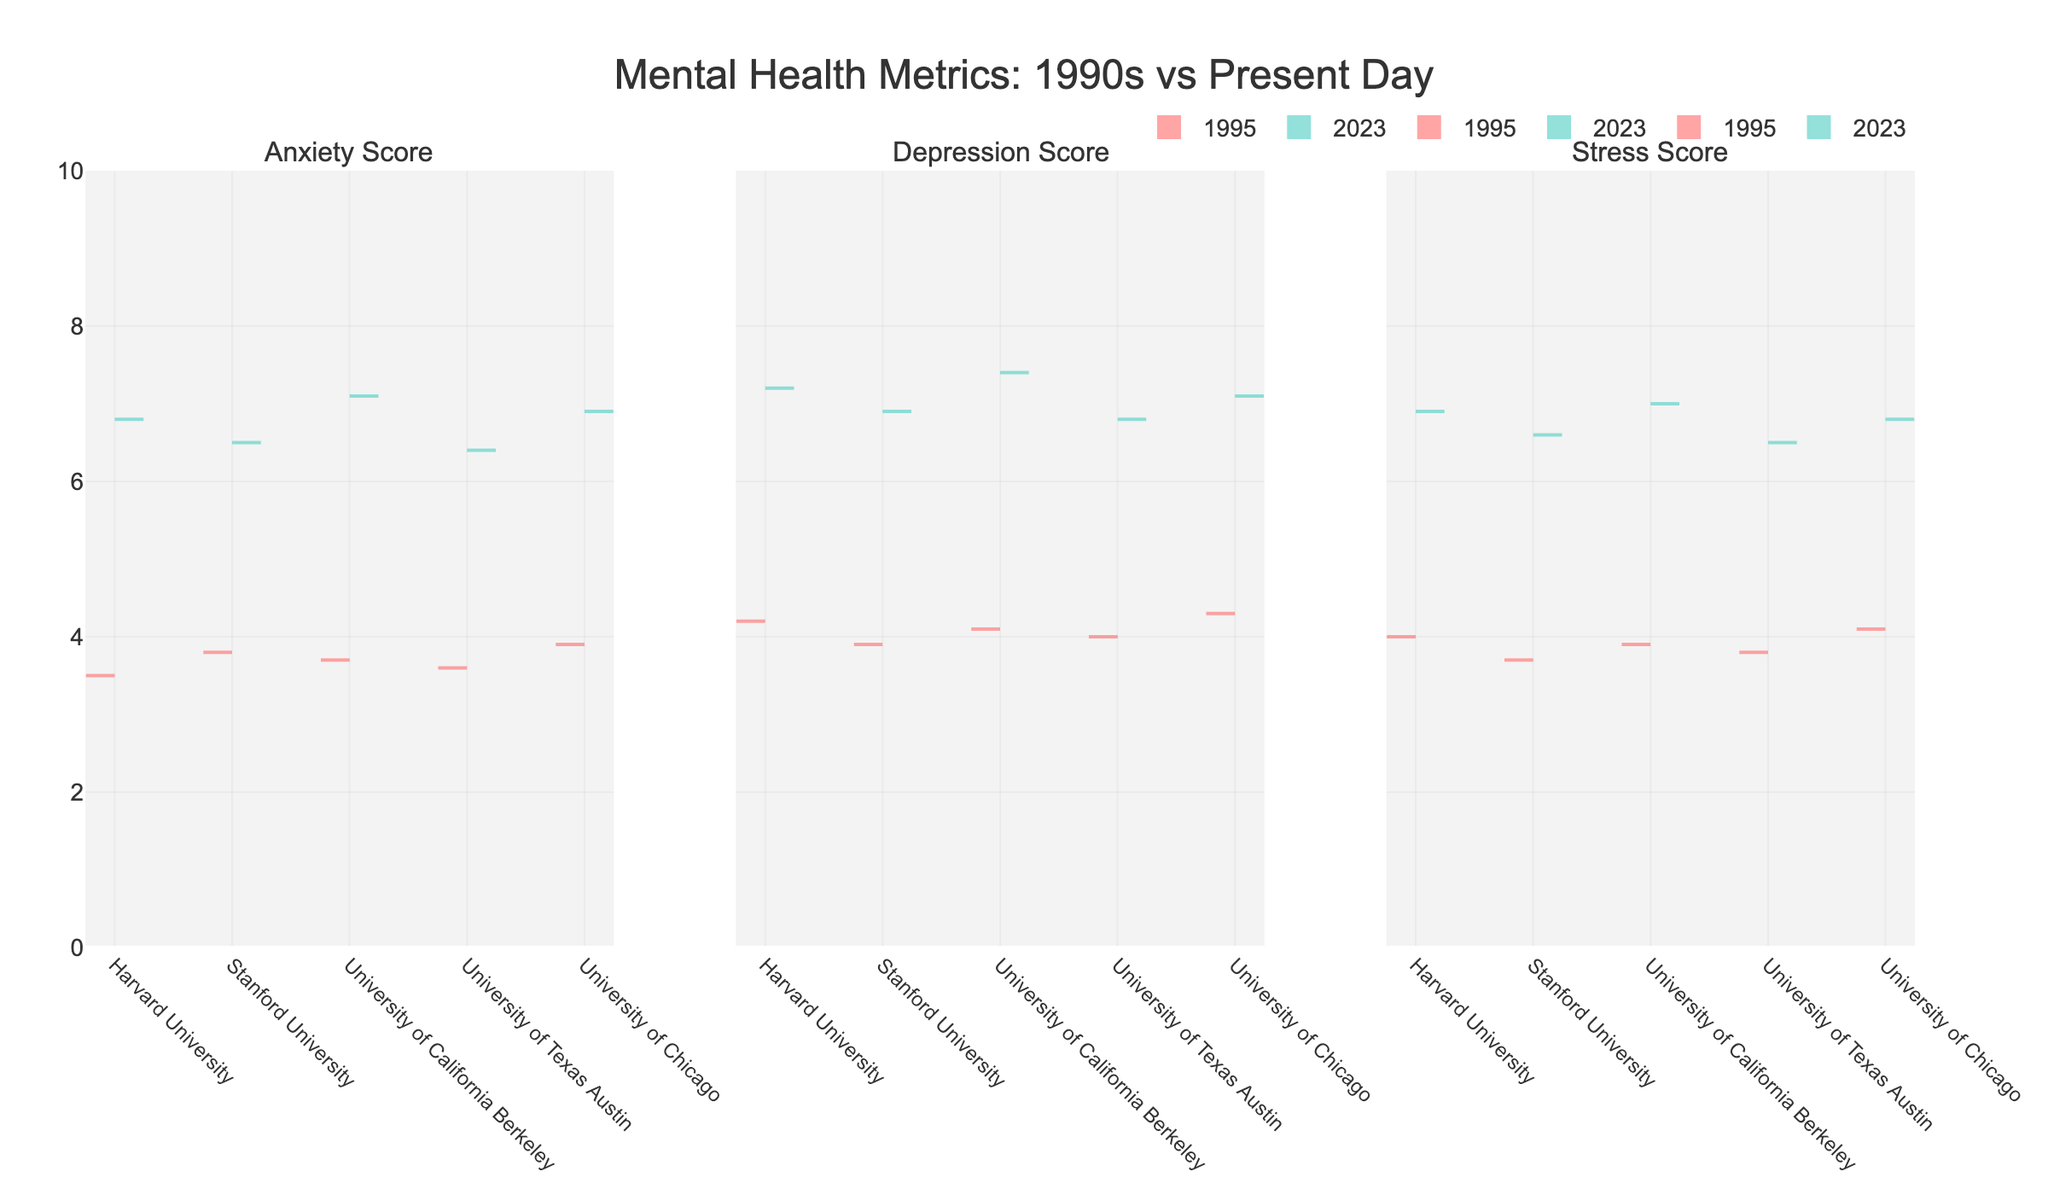Which year is represented by the light blue color? The Split Violin Chart uses two colors to distinguish between years. Light blue represents 2023.
Answer: 2023 What is the title of the chart? The title is prominently displayed at the top of the chart. It reads "Mental Health Metrics: 1990s vs Present Day".
Answer: Mental Health Metrics: 1990s vs Present Day Which metric shows the greatest increase from 1995 to 2023 at Harvard University? By comparing the split violin plots for Harvard University across all three metrics, the increases in scores from 1995 to 2023 can be observed. The Anxiety Score has an increase from 3.5 to 6.8.
Answer: Anxiety Score Compare the median Anxiety Score between the 1990s and the present day. What do you notice? The viollin chart slices through the distributions for Anxiety Scores in 1995 and 2023. The central tendency lines show that the median score is significantly higher in 2023.
Answer: Median Anxiety Score is higher in 2023 In which metric is the difference in scores between 1995 and 2023 most consistent across all universities? By evaluating the difference in scores for Anxiety, Depression, and Stress across the universities, Stress Scores show the most consistent pattern of increase.
Answer: Stress Score What can you infer about the overall mental health of college students from the 1990s to the present day? The figure shows that for Anxiety, Depression, and Stress Scores, there are significant increases in 2023 compared to 1995 across all universities, suggesting worsening mental health.
Answer: Worsened mental health Which university has the highest Stress Score in 2023? Reviewing the uppermost point of the light blue violin segment for Stress Scores, University of California Berkeley stands out with the highest score of 7.0.
Answer: University of California Berkeley How does the Depression Score for Stanford University in 1995 compare to its Anxiety Score in the same year? The Depression Score for Stanford University in 1995 is 3.9, which is slightly lower than the Anxiety Score of 3.8.
Answer: Depression Score is slightly higher than Anxiety Score What is the difference in the median Stress Score for University of Chicago between 1995 and 2023? The median Stress Score for University of Chicago in 1995 is 4.1. In 2023, it is 6.8. The difference is calculated as 6.8 - 4.1.
Answer: 2.7 